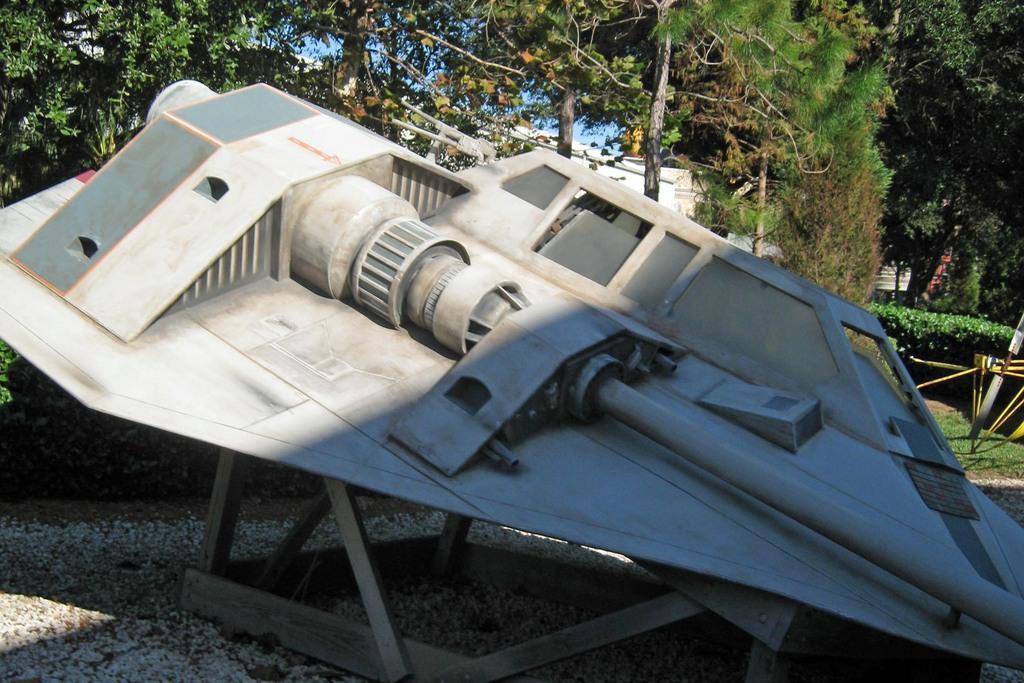In one or two sentences, can you explain what this image depicts? In the center of the image there is a depiction of a aircraft. In the background of the image there are trees. At the bottom of the image there are stones. 